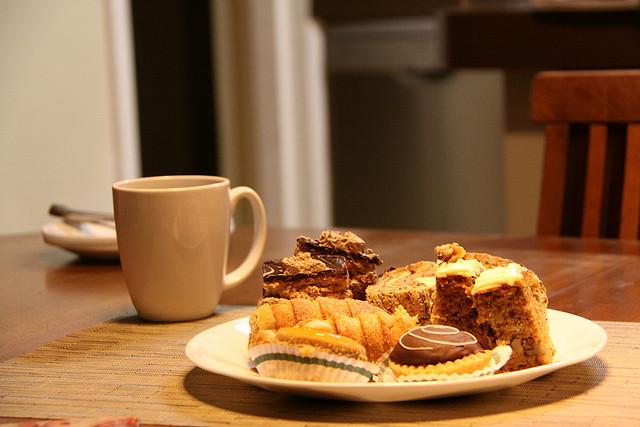Is the food on a plate?
Be succinct. Yes. What color is the table?
Keep it brief. Brown. Could this be someone's breakfast?
Keep it brief. Yes. 